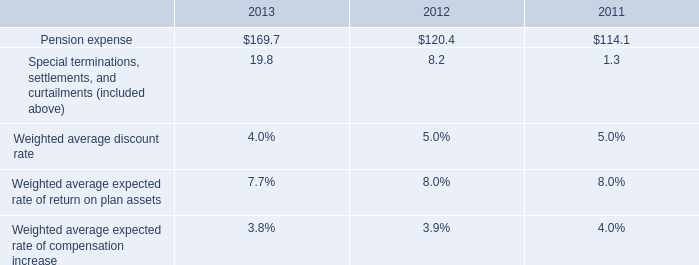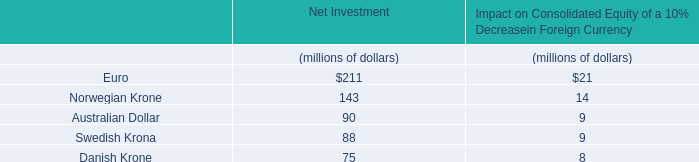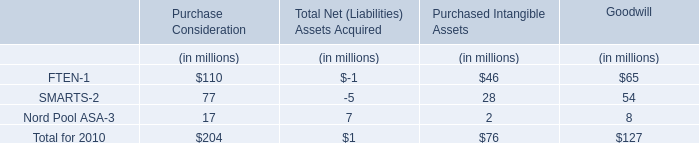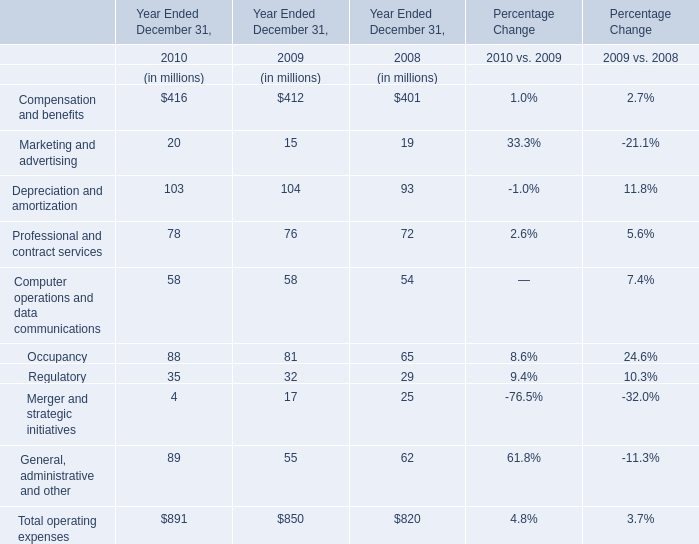How many element exceed the average of Computer operations and Professional and contract services data communications and in 2010? 
Answer: 6. 